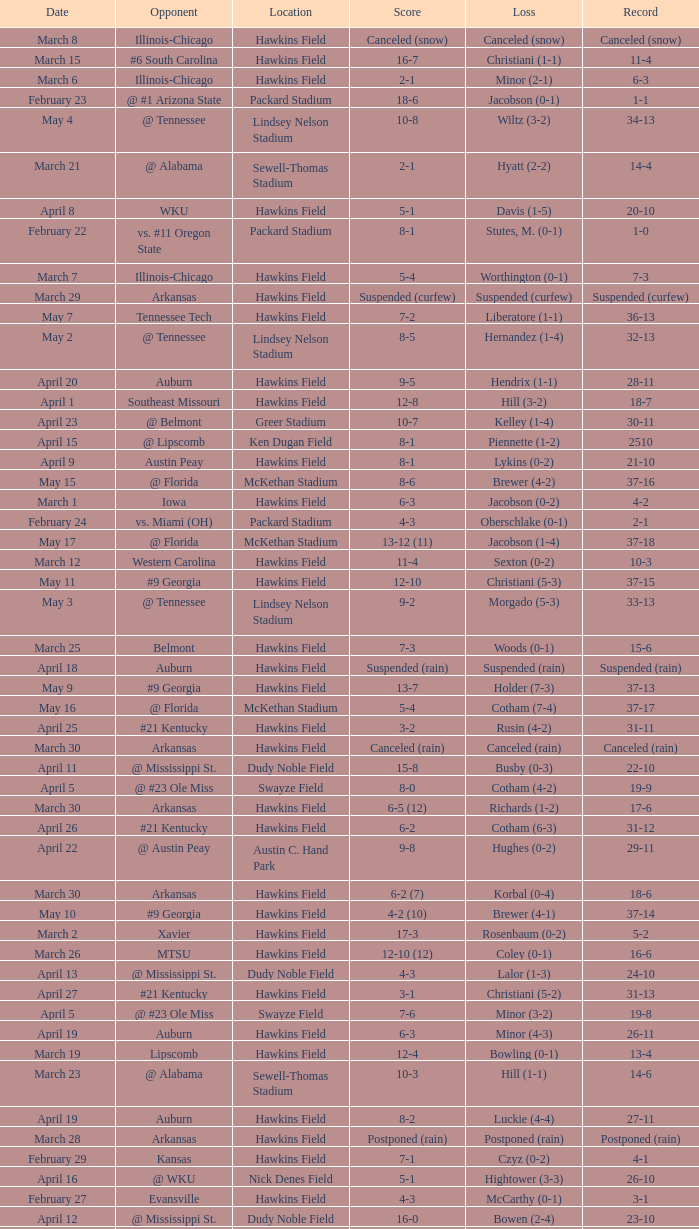What was the location of the game when the record was 2-1? Packard Stadium. 